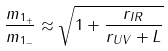<formula> <loc_0><loc_0><loc_500><loc_500>\frac { m _ { 1 _ { + } } } { m _ { 1 _ { - } } } \approx \sqrt { 1 + \frac { r _ { I R } } { r _ { U V } + L } }</formula> 